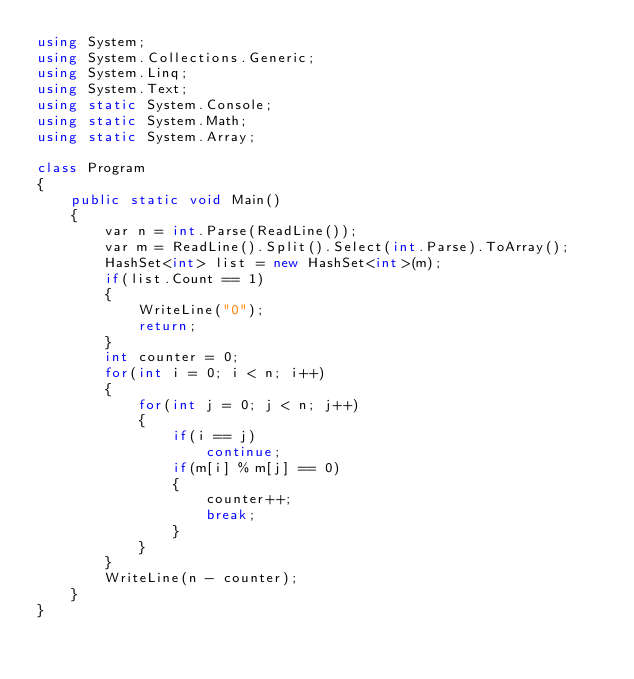Convert code to text. <code><loc_0><loc_0><loc_500><loc_500><_C#_>using System;
using System.Collections.Generic;
using System.Linq;
using System.Text;
using static System.Console;
using static System.Math;
using static System.Array;

class Program
{
    public static void Main()
    {
        var n = int.Parse(ReadLine());
        var m = ReadLine().Split().Select(int.Parse).ToArray();
        HashSet<int> list = new HashSet<int>(m);
        if(list.Count == 1)
        {
            WriteLine("0");
            return;
        }
        int counter = 0;
        for(int i = 0; i < n; i++)
        {
            for(int j = 0; j < n; j++)
            {
                if(i == j)
                    continue;
                if(m[i] % m[j] == 0)
                {
                    counter++;
                    break;
                }
            }
        }
        WriteLine(n - counter);
    }
}
</code> 